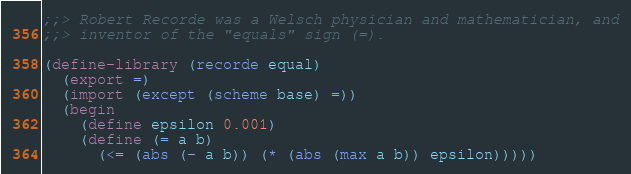<code> <loc_0><loc_0><loc_500><loc_500><_Scheme_>;;> Robert Recorde was a Welsch physician and mathematician, and
;;> inventor of the "equals" sign (=).

(define-library (recorde equal)
  (export =)
  (import (except (scheme base) =))
  (begin
    (define epsilon 0.001)
    (define (= a b)
      (<= (abs (- a b)) (* (abs (max a b)) epsilon)))))
</code> 